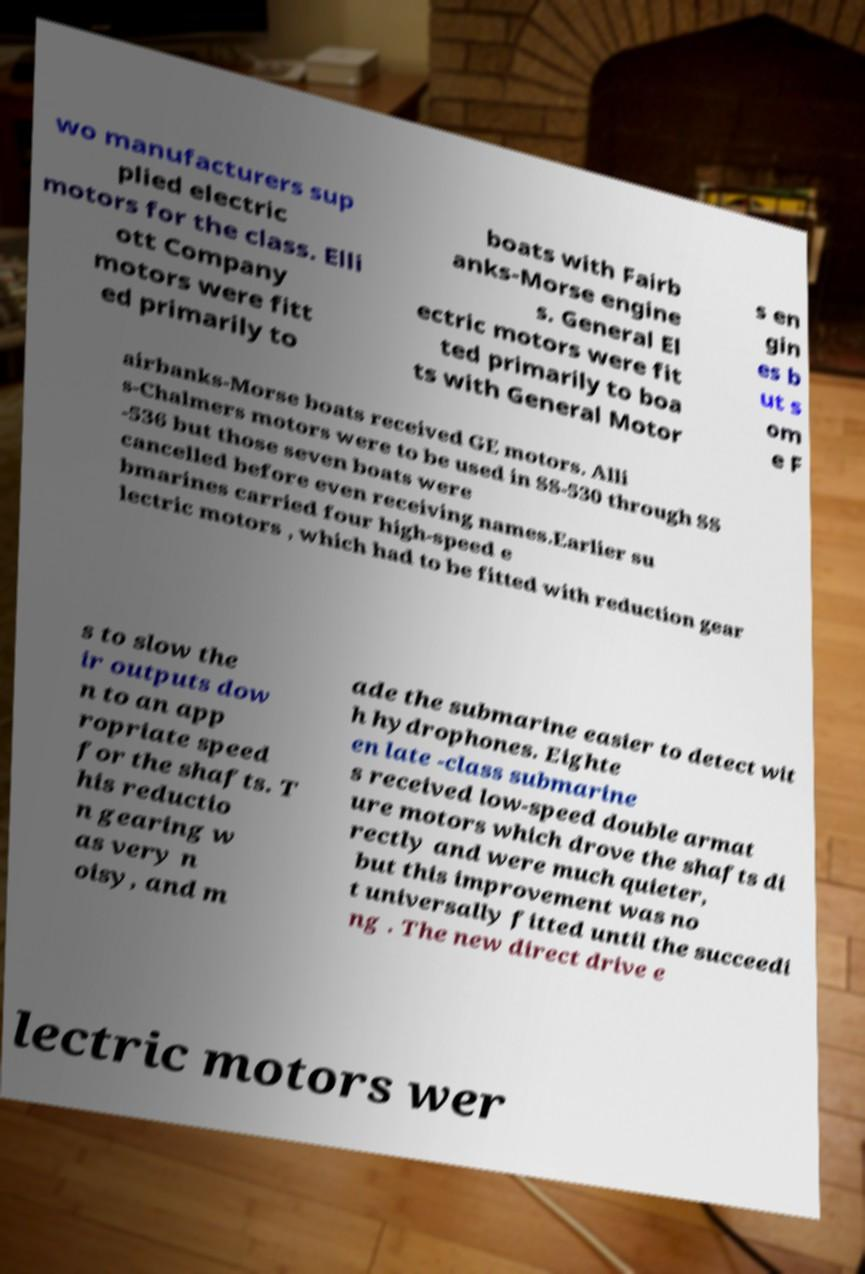There's text embedded in this image that I need extracted. Can you transcribe it verbatim? wo manufacturers sup plied electric motors for the class. Elli ott Company motors were fitt ed primarily to boats with Fairb anks-Morse engine s. General El ectric motors were fit ted primarily to boa ts with General Motor s en gin es b ut s om e F airbanks-Morse boats received GE motors. Alli s-Chalmers motors were to be used in SS-530 through SS -536 but those seven boats were cancelled before even receiving names.Earlier su bmarines carried four high-speed e lectric motors , which had to be fitted with reduction gear s to slow the ir outputs dow n to an app ropriate speed for the shafts. T his reductio n gearing w as very n oisy, and m ade the submarine easier to detect wit h hydrophones. Eighte en late -class submarine s received low-speed double armat ure motors which drove the shafts di rectly and were much quieter, but this improvement was no t universally fitted until the succeedi ng . The new direct drive e lectric motors wer 